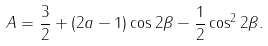Convert formula to latex. <formula><loc_0><loc_0><loc_500><loc_500>A = { \frac { 3 } { 2 } } + ( 2 a - 1 ) \cos 2 \beta - { \frac { 1 } { 2 } } \cos ^ { 2 } 2 \beta .</formula> 